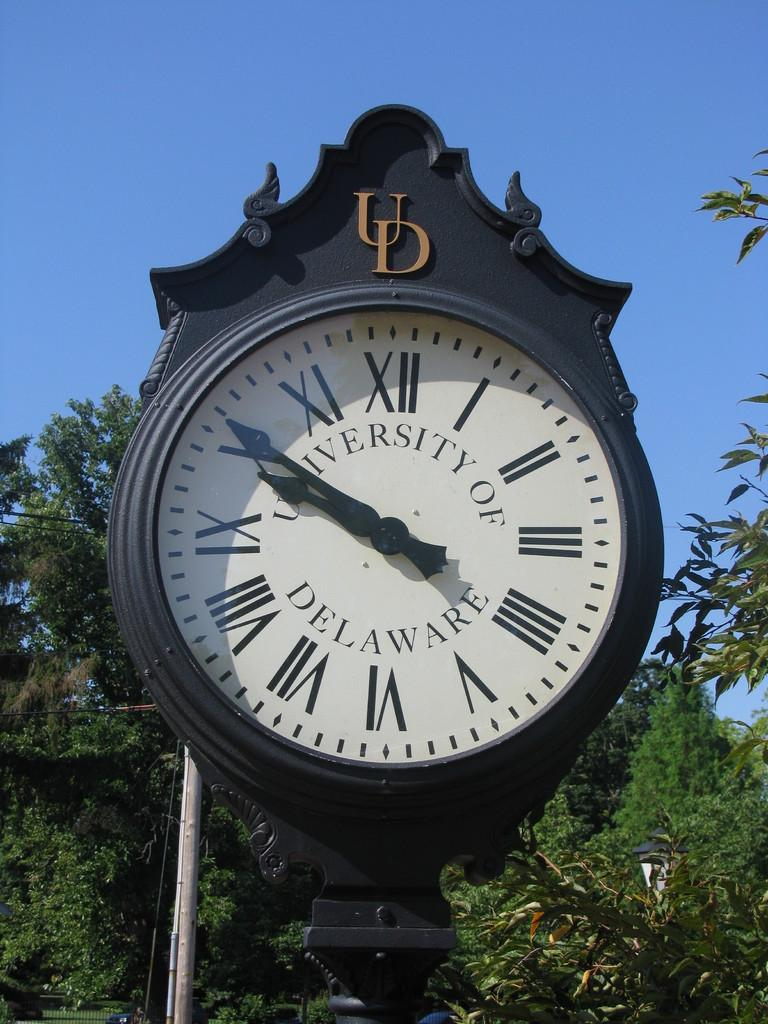<image>
Give a short and clear explanation of the subsequent image. Outdoor university of deleware clock with roman numerals on it. 